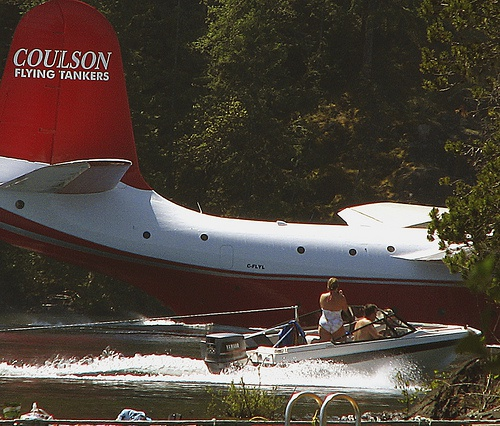Describe the objects in this image and their specific colors. I can see airplane in black, maroon, gray, and white tones, boat in black, white, gray, and darkgray tones, people in black, maroon, and gray tones, and people in black, maroon, and gray tones in this image. 